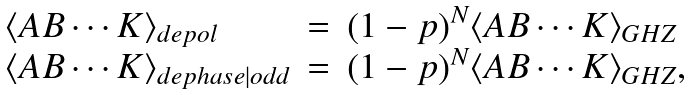Convert formula to latex. <formula><loc_0><loc_0><loc_500><loc_500>\begin{array} { l c l } \langle A B \cdots K \rangle _ { d e p o l } & = & ( 1 - p ) ^ { N } \langle A B \cdots K \rangle _ { G H Z } \\ \langle A B \cdots K \rangle _ { d e p h a s e | o d d } & = & ( 1 - p ) ^ { N } \langle A B \cdots K \rangle _ { G H Z } , \end{array}</formula> 